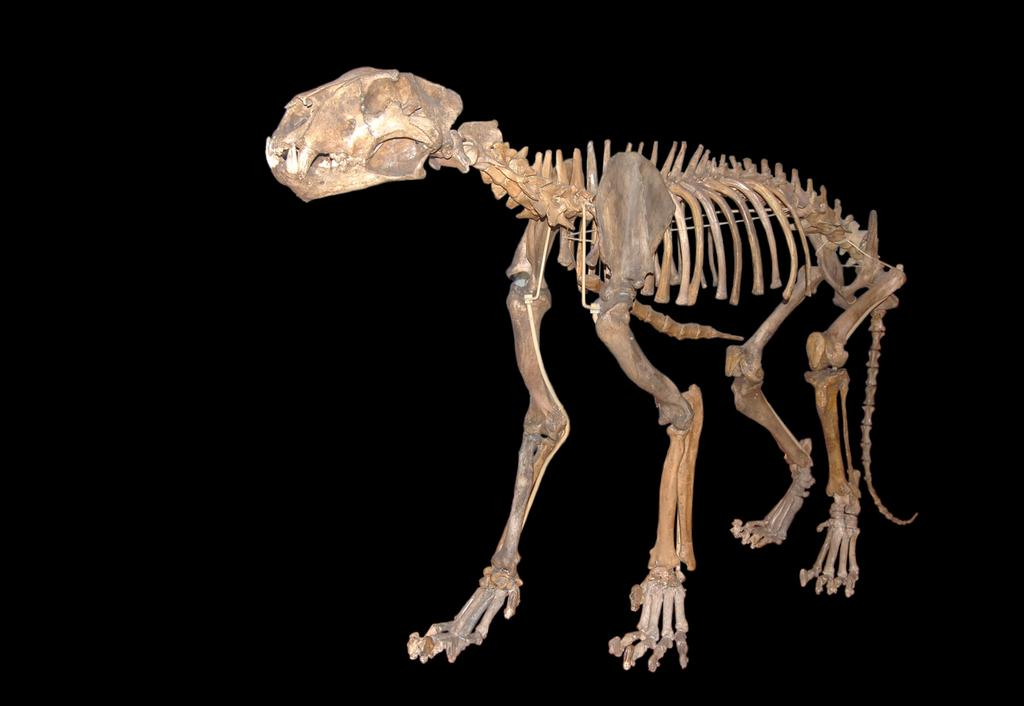What is the main subject of the image? The main subject of the image is a skeleton of an animal. What can be observed about the background of the image? The background of the image is dark. What type of credit card is the animal holding in the image? There is no credit card or animal holding anything in the image; it features a skeleton of an animal with a dark background. 